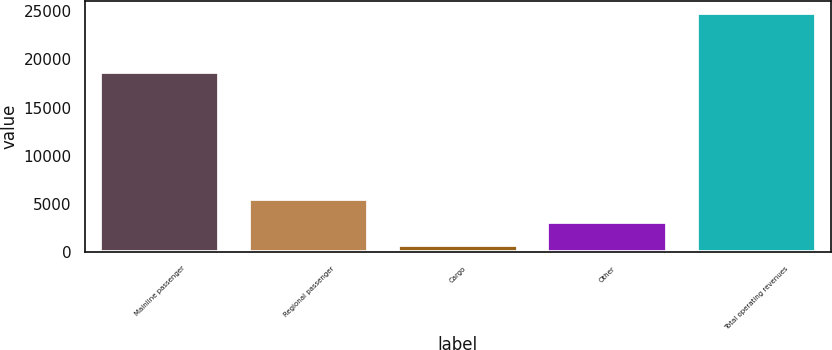Convert chart. <chart><loc_0><loc_0><loc_500><loc_500><bar_chart><fcel>Mainline passenger<fcel>Regional passenger<fcel>Cargo<fcel>Other<fcel>Total operating revenues<nl><fcel>18743<fcel>5511<fcel>675<fcel>3093<fcel>24855<nl></chart> 